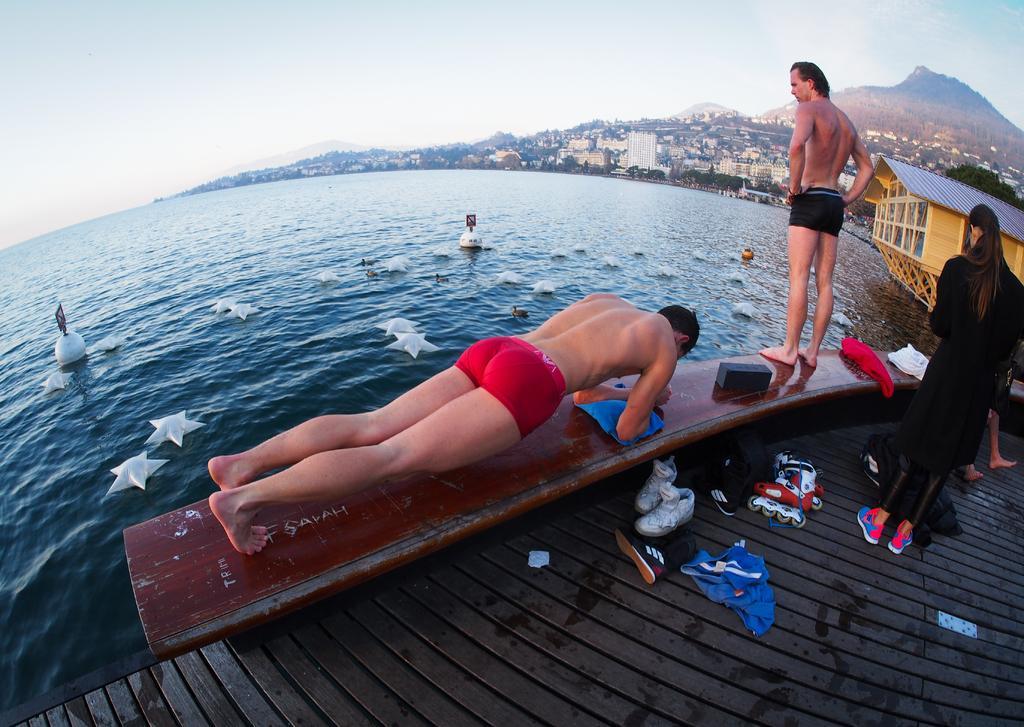Please provide a concise description of this image. In front of the picture, we see a man is exercising. Beside him, we see a man is standing on the bench. Behind him, we see a woman is standing on the bridge. Beside her, we see clothes and shoes placed under the bench. In the middle of the picture, we see water and this water might be in the river. We see the star shaped objects are placed in the water. On the right side, we see a building. There are trees, hills and buildings in the background. At the top, we see the sky. 